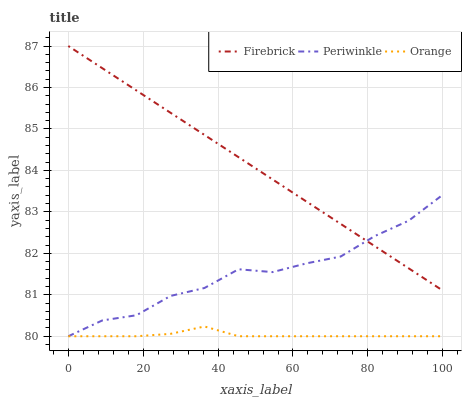Does Orange have the minimum area under the curve?
Answer yes or no. Yes. Does Firebrick have the maximum area under the curve?
Answer yes or no. Yes. Does Periwinkle have the minimum area under the curve?
Answer yes or no. No. Does Periwinkle have the maximum area under the curve?
Answer yes or no. No. Is Firebrick the smoothest?
Answer yes or no. Yes. Is Periwinkle the roughest?
Answer yes or no. Yes. Is Periwinkle the smoothest?
Answer yes or no. No. Is Firebrick the roughest?
Answer yes or no. No. Does Orange have the lowest value?
Answer yes or no. Yes. Does Firebrick have the lowest value?
Answer yes or no. No. Does Firebrick have the highest value?
Answer yes or no. Yes. Does Periwinkle have the highest value?
Answer yes or no. No. Is Orange less than Firebrick?
Answer yes or no. Yes. Is Firebrick greater than Orange?
Answer yes or no. Yes. Does Periwinkle intersect Firebrick?
Answer yes or no. Yes. Is Periwinkle less than Firebrick?
Answer yes or no. No. Is Periwinkle greater than Firebrick?
Answer yes or no. No. Does Orange intersect Firebrick?
Answer yes or no. No. 